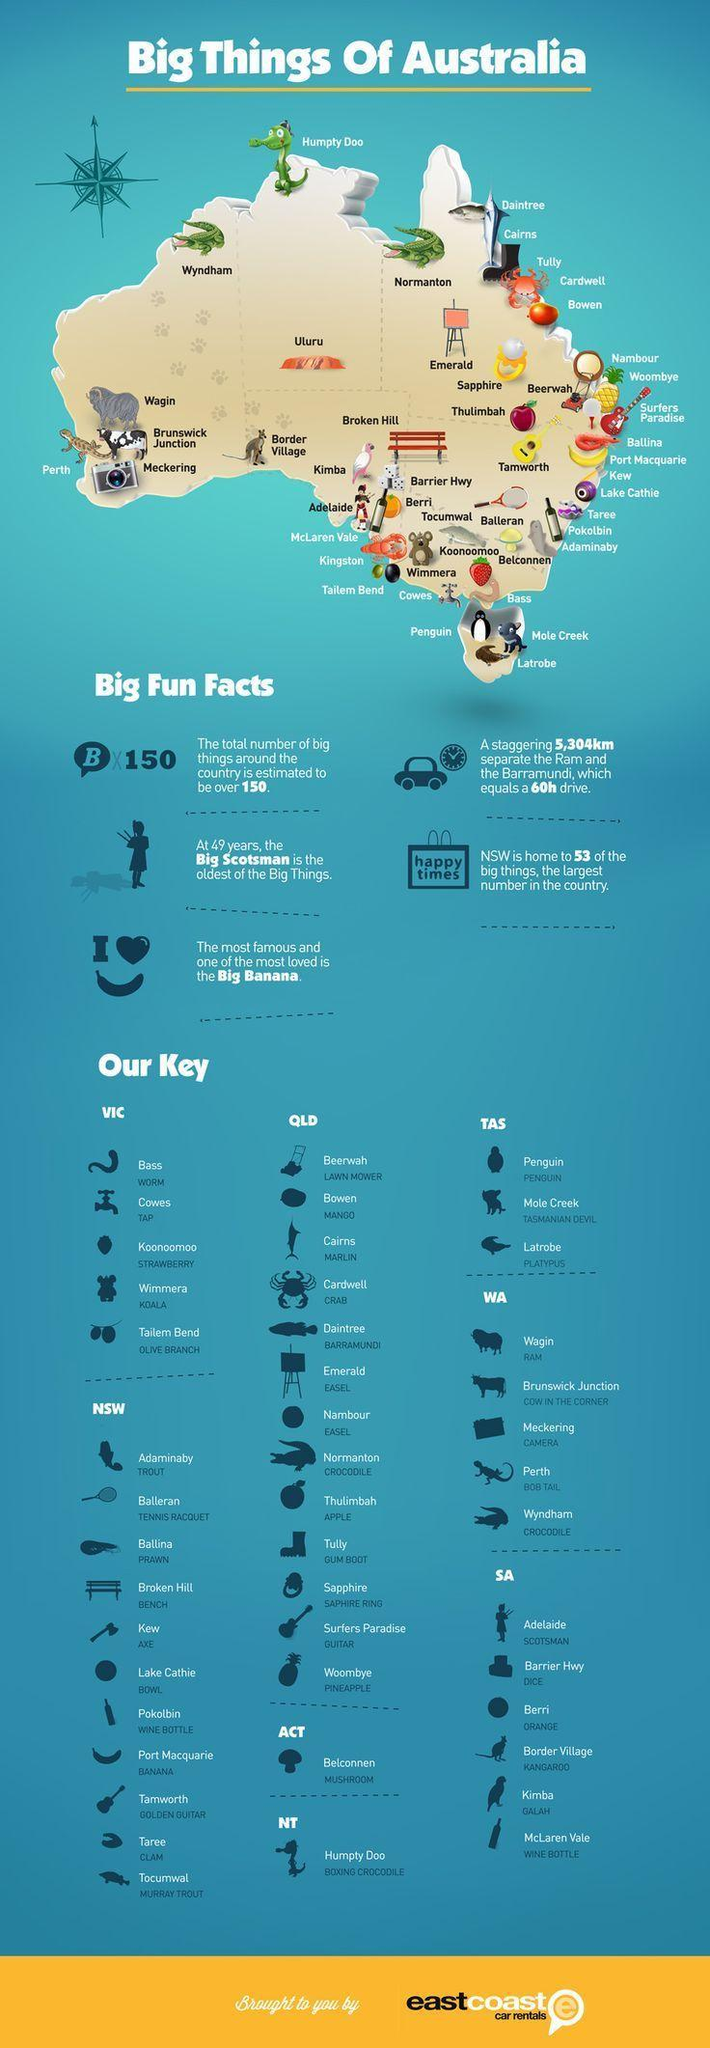Which is the oldest of the "big things"?
Answer the question with a short phrase. the big scotsman 